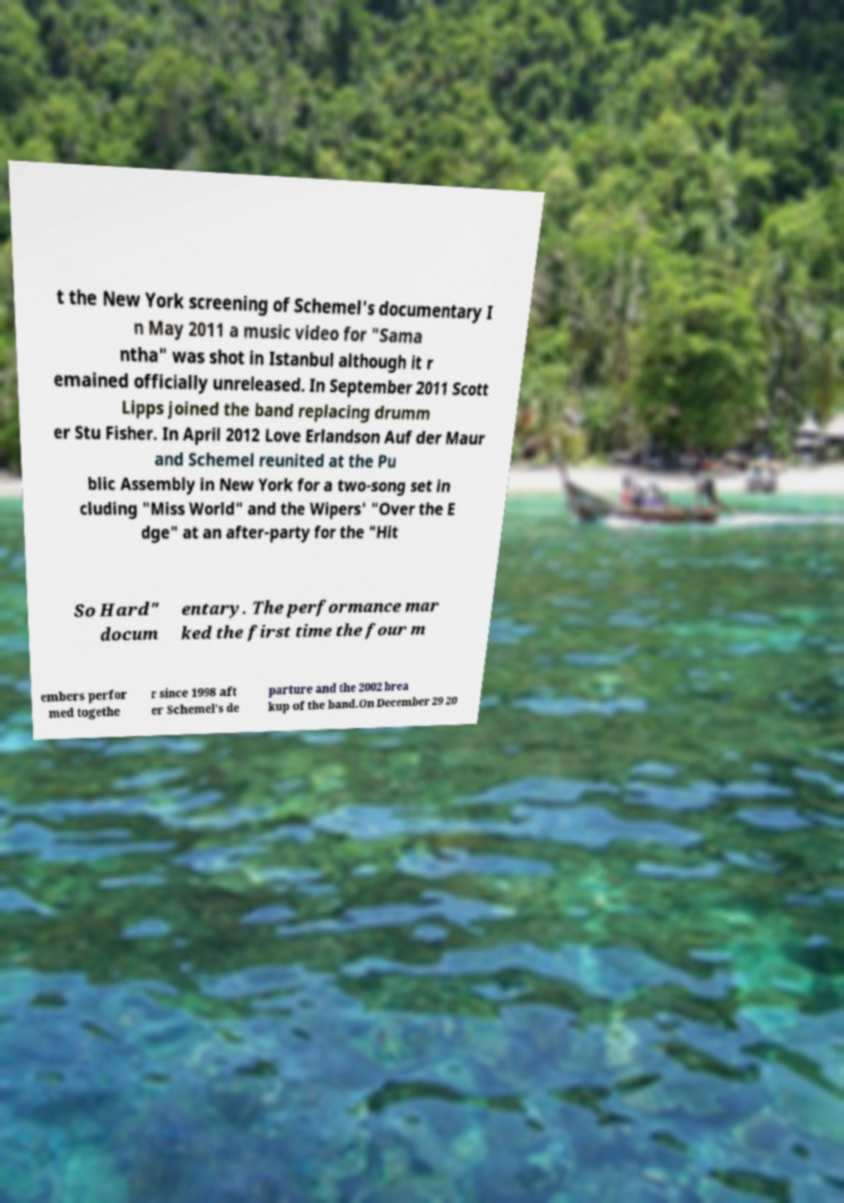Please identify and transcribe the text found in this image. t the New York screening of Schemel's documentary I n May 2011 a music video for "Sama ntha" was shot in Istanbul although it r emained officially unreleased. In September 2011 Scott Lipps joined the band replacing drumm er Stu Fisher. In April 2012 Love Erlandson Auf der Maur and Schemel reunited at the Pu blic Assembly in New York for a two-song set in cluding "Miss World" and the Wipers' "Over the E dge" at an after-party for the "Hit So Hard" docum entary. The performance mar ked the first time the four m embers perfor med togethe r since 1998 aft er Schemel's de parture and the 2002 brea kup of the band.On December 29 20 